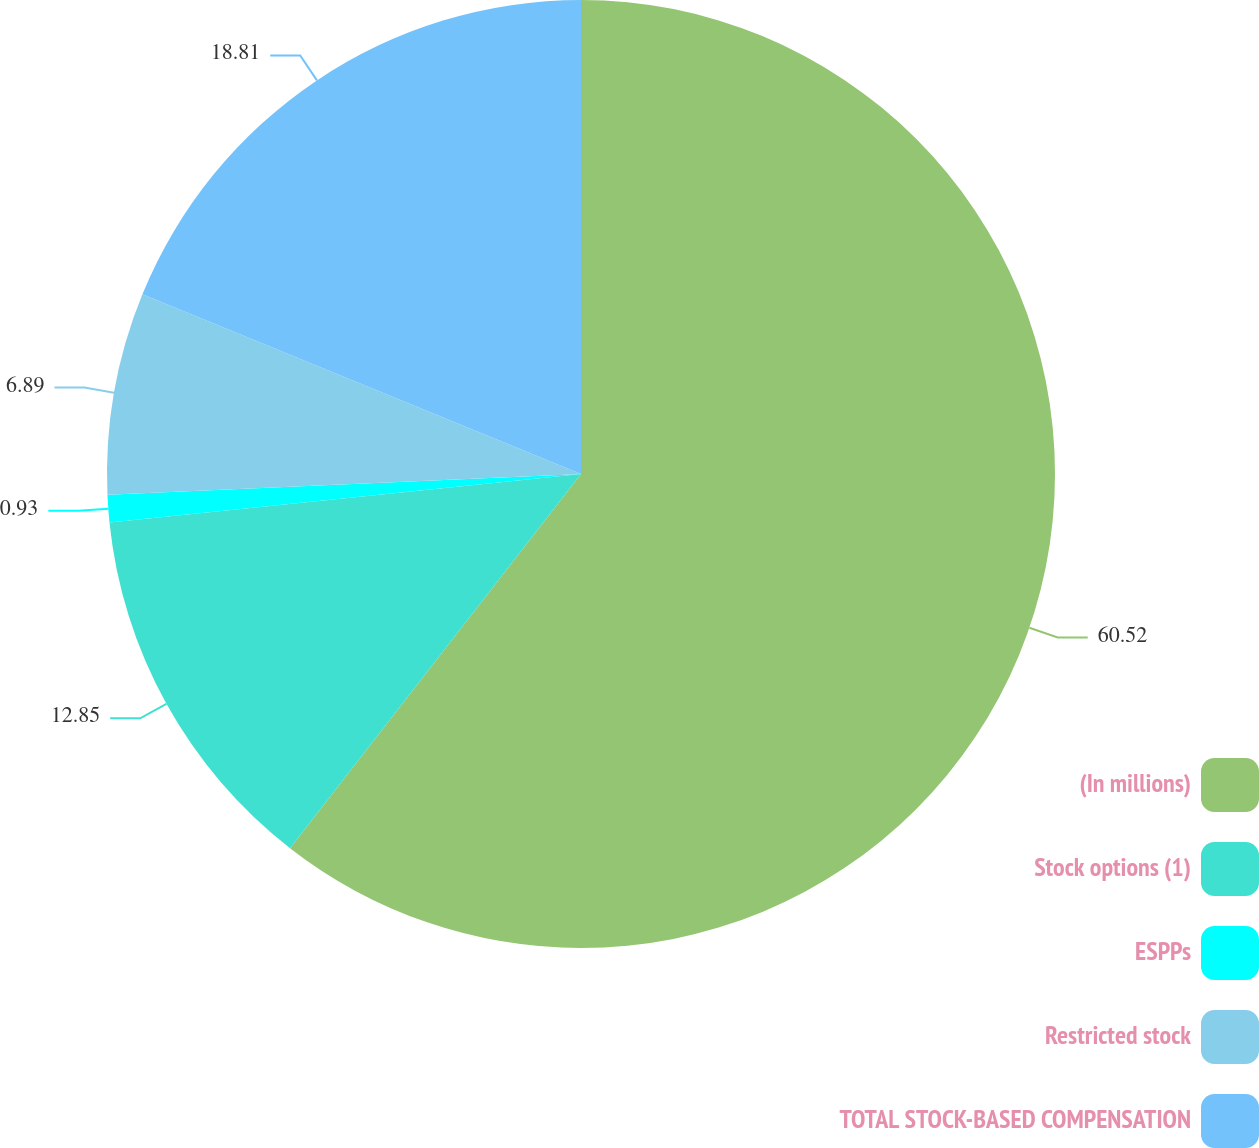<chart> <loc_0><loc_0><loc_500><loc_500><pie_chart><fcel>(In millions)<fcel>Stock options (1)<fcel>ESPPs<fcel>Restricted stock<fcel>TOTAL STOCK-BASED COMPENSATION<nl><fcel>60.52%<fcel>12.85%<fcel>0.93%<fcel>6.89%<fcel>18.81%<nl></chart> 